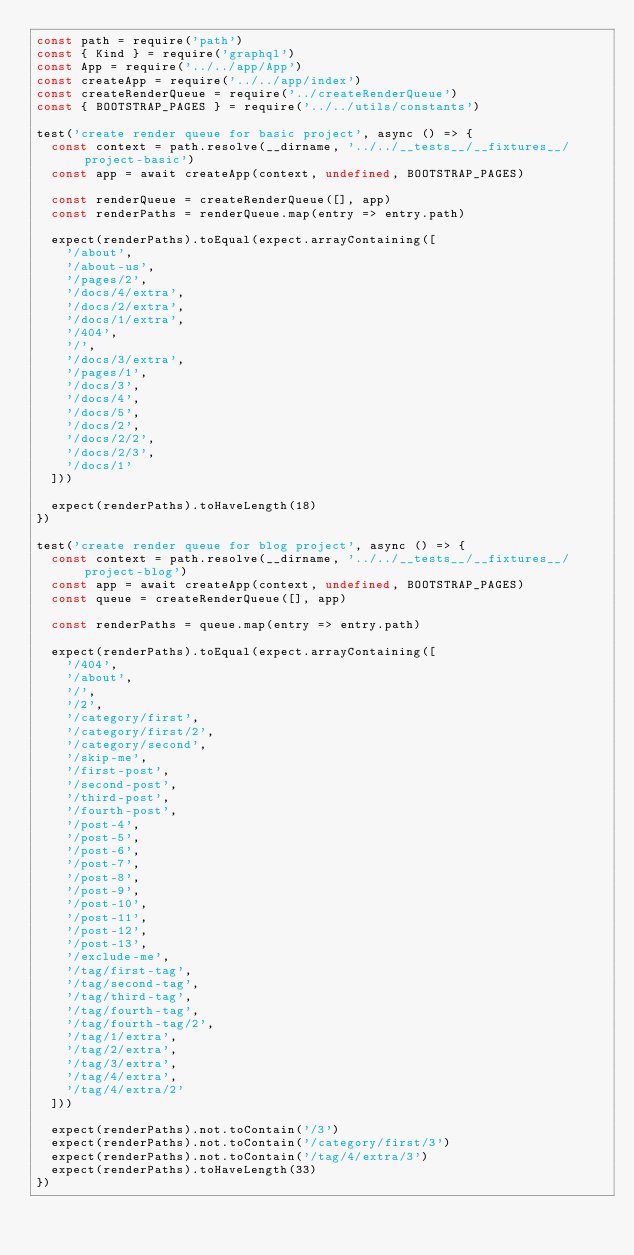<code> <loc_0><loc_0><loc_500><loc_500><_JavaScript_>const path = require('path')
const { Kind } = require('graphql')
const App = require('../../app/App')
const createApp = require('../../app/index')
const createRenderQueue = require('../createRenderQueue')
const { BOOTSTRAP_PAGES } = require('../../utils/constants')

test('create render queue for basic project', async () => {
  const context = path.resolve(__dirname, '../../__tests__/__fixtures__/project-basic')
  const app = await createApp(context, undefined, BOOTSTRAP_PAGES)

  const renderQueue = createRenderQueue([], app)
  const renderPaths = renderQueue.map(entry => entry.path)

  expect(renderPaths).toEqual(expect.arrayContaining([
    '/about',
    '/about-us',
    '/pages/2',
    '/docs/4/extra',
    '/docs/2/extra',
    '/docs/1/extra',
    '/404',
    '/',
    '/docs/3/extra',
    '/pages/1',
    '/docs/3',
    '/docs/4',
    '/docs/5',
    '/docs/2',
    '/docs/2/2',
    '/docs/2/3',
    '/docs/1'
  ]))

  expect(renderPaths).toHaveLength(18)
})

test('create render queue for blog project', async () => {
  const context = path.resolve(__dirname, '../../__tests__/__fixtures__/project-blog')
  const app = await createApp(context, undefined, BOOTSTRAP_PAGES)
  const queue = createRenderQueue([], app)

  const renderPaths = queue.map(entry => entry.path)

  expect(renderPaths).toEqual(expect.arrayContaining([
    '/404',
    '/about',
    '/',
    '/2',
    '/category/first',
    '/category/first/2',
    '/category/second',
    '/skip-me',
    '/first-post',
    '/second-post',
    '/third-post',
    '/fourth-post',
    '/post-4',
    '/post-5',
    '/post-6',
    '/post-7',
    '/post-8',
    '/post-9',
    '/post-10',
    '/post-11',
    '/post-12',
    '/post-13',
    '/exclude-me',
    '/tag/first-tag',
    '/tag/second-tag',
    '/tag/third-tag',
    '/tag/fourth-tag',
    '/tag/fourth-tag/2',
    '/tag/1/extra',
    '/tag/2/extra',
    '/tag/3/extra',
    '/tag/4/extra',
    '/tag/4/extra/2'
  ]))

  expect(renderPaths).not.toContain('/3')
  expect(renderPaths).not.toContain('/category/first/3')
  expect(renderPaths).not.toContain('/tag/4/extra/3')
  expect(renderPaths).toHaveLength(33)
})
</code> 